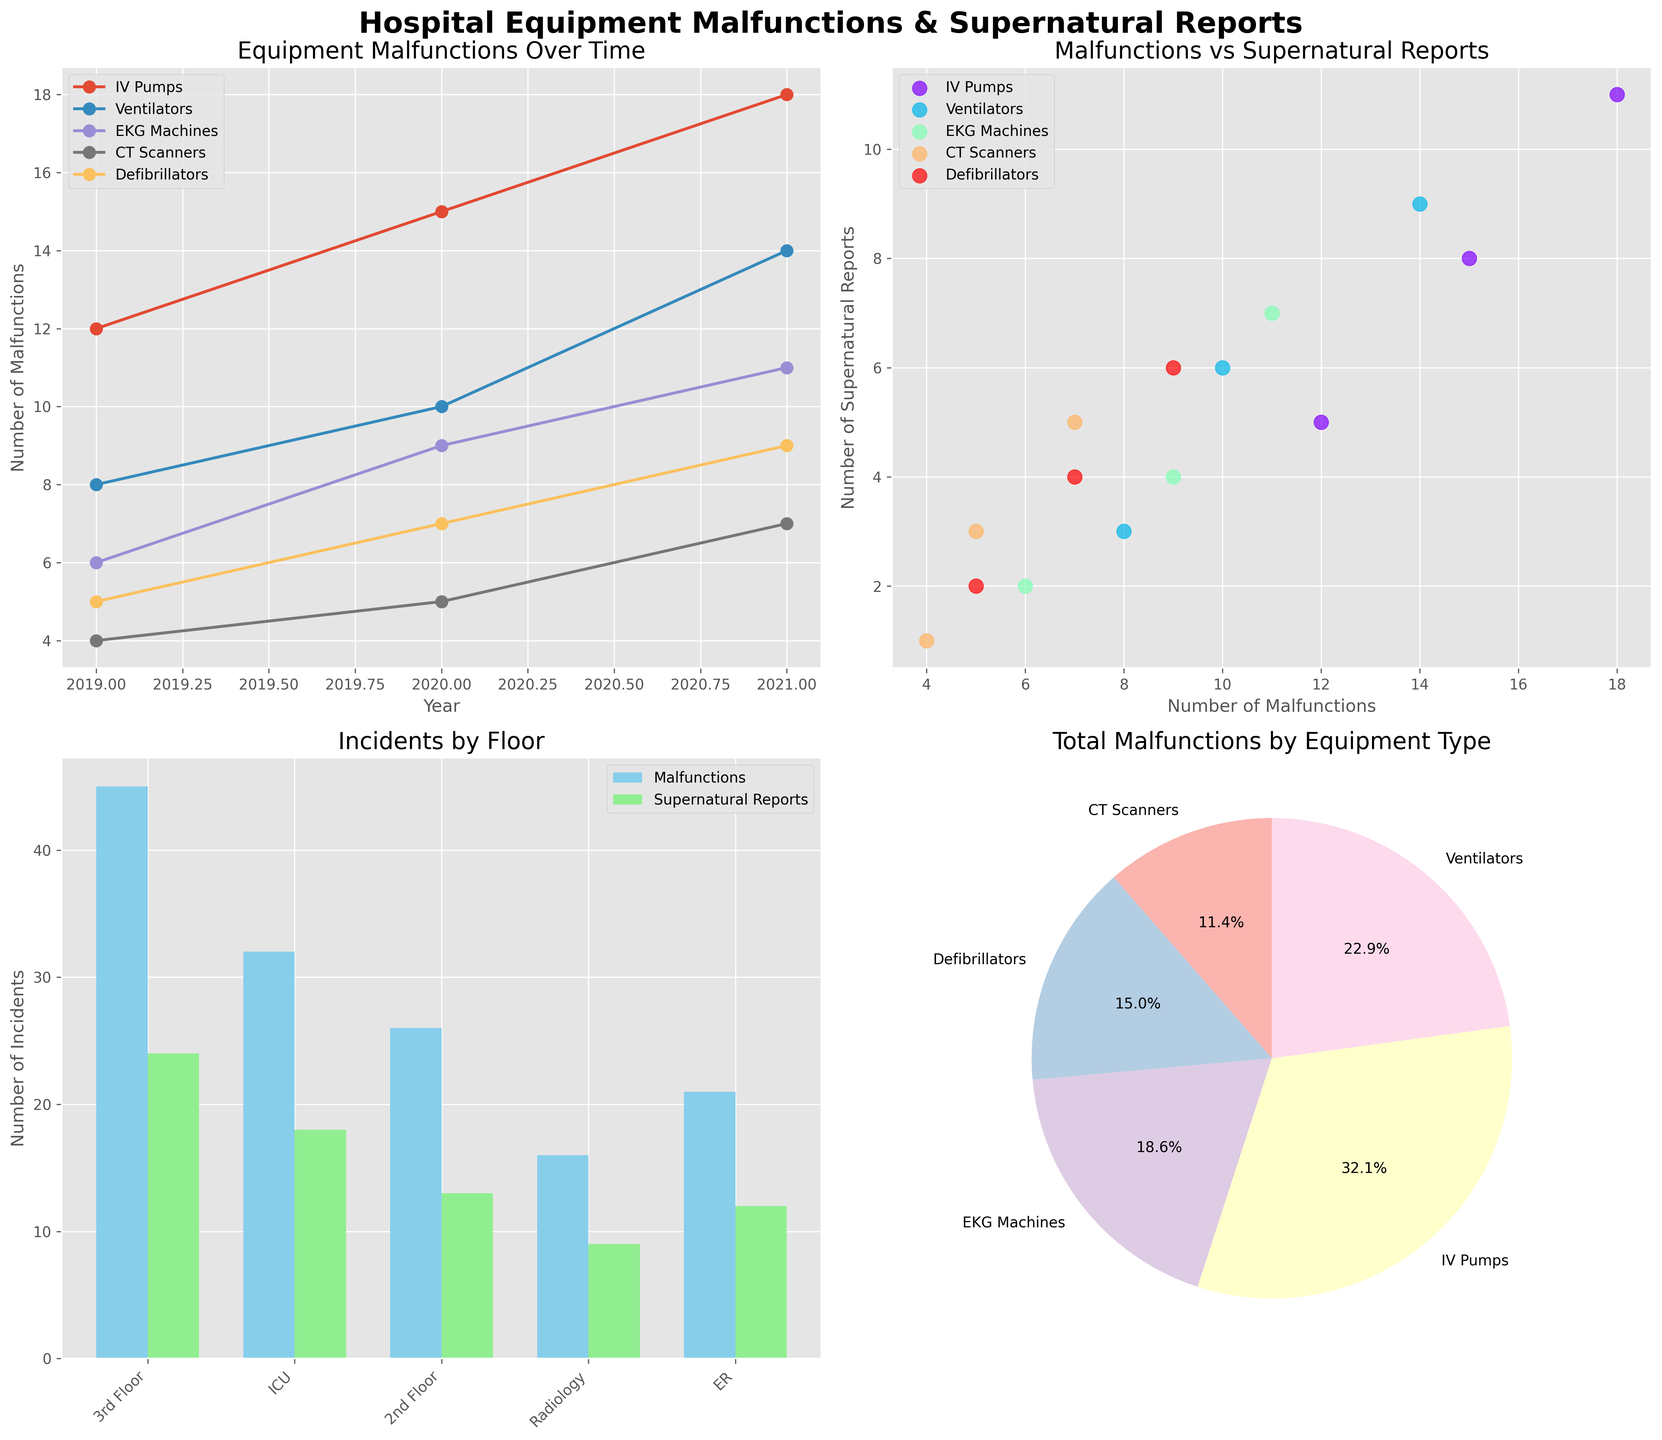What is the title of the first plot? The title of the first plot is displayed at the top of the first subplot and reads as "Equipment Malfunctions Over Time".
Answer: Equipment Malfunctions Over Time How many equipment types are represented in the first plot? By counting the distinct markers with labels on the first plot, we can see there are 5 equipment types, one for each line.
Answer: 5 Which equipment type had the highest number of malfunctions in 2021 according to the first plot? In the line plot for 2021, the IV Pumps show the highest marker, indicating the highest number of malfunctions among the equipment types in that year.
Answer: IV Pumps What is the relationship between malfunctions and supernatural reports for ventilators? Looking at the scatter plot, each equipment type is plotted with malfunctions on the x-axis and supernatural reports on the y-axis. For ventilators, as malfunctions increase from 8 to 14, supernatural reports increase from 3 to 9.
Answer: Positive correlation Which floor had the highest total number of incidents according to the third plot? Inspecting the stacked bar chart, the ICU floor has the highest combined height of bars for malfunctions and supernatural reports, indicating the highest total number of incidents.
Answer: ICU How does the number of EKG machine malfunctions change from 2019 to 2021? According to the first subplot, the number of malfunctions of EKG machines increased yearly from 6 in 2019 to 11 in 2021.
Answer: Increases Which equipment type contributed the most to total malfunctions as shown in the fourth subplot? The pie chart clearly indicates that IV Pumps have the largest segment, signifying the highest contribution to total malfunctions.
Answer: IV Pumps What can be inferred about the 3rd floor from the third plot? By observing the bar heights in the stacked bar chart for the 3rd floor, we see relatively high numbers for the malfunctions and supernatural reports, suggesting frequent incidents.
Answer: Frequent incidents Do CT scanners display a significant relationship between malfunctions and supernatural reports? In the scatter plot, the points for CT Scanners (represented consistently by their unique color and label) show a moderate positive trend as malfunctions increase from 4 to 7 and reports increase from 1 to 5.
Answer: Yes What pattern do you see in the number of malfunctions over the years from the first plot? Each line in the first plot representing an equipment type generally slopes upward from 2019 to 2021, indicating an increasing trend in malfunctions over time.
Answer: Increasing 